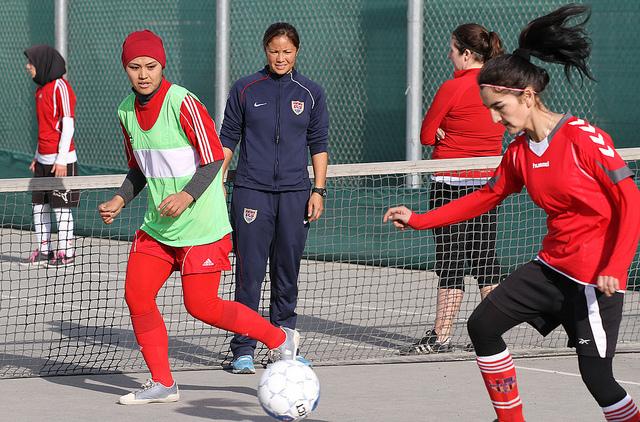Is this height and length net more commonly seen with players of another sport?
Give a very brief answer. Yes. What is the woman in blue doing?
Concise answer only. Watching. How many balls are in the photo?
Answer briefly. 1. 